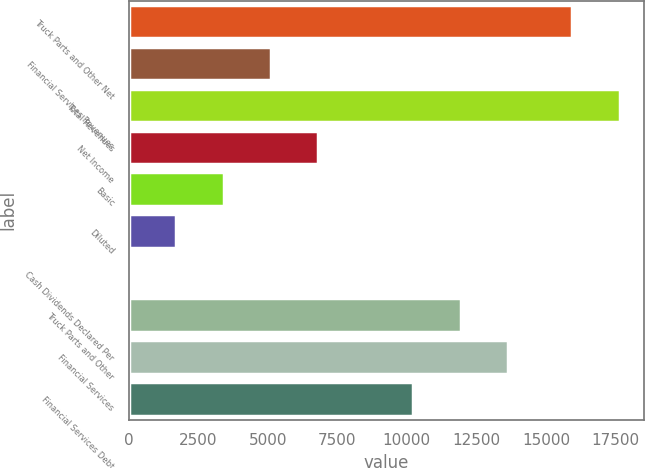Convert chart to OTSL. <chart><loc_0><loc_0><loc_500><loc_500><bar_chart><fcel>Truck Parts and Other Net<fcel>Financial Services Revenues<fcel>Total Revenues<fcel>Net Income<fcel>Basic<fcel>Diluted<fcel>Cash Dividends Declared Per<fcel>Truck Parts and Other<fcel>Financial Services<fcel>Financial Services Debt<nl><fcel>15951.7<fcel>5116.25<fcel>17656.6<fcel>6821.14<fcel>3411.36<fcel>1706.47<fcel>1.58<fcel>11935.8<fcel>13640.7<fcel>10230.9<nl></chart> 